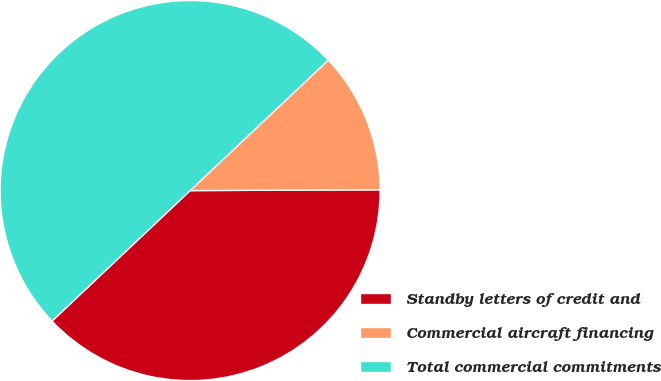Convert chart to OTSL. <chart><loc_0><loc_0><loc_500><loc_500><pie_chart><fcel>Standby letters of credit and<fcel>Commercial aircraft financing<fcel>Total commercial commitments<nl><fcel>38.02%<fcel>11.98%<fcel>50.0%<nl></chart> 